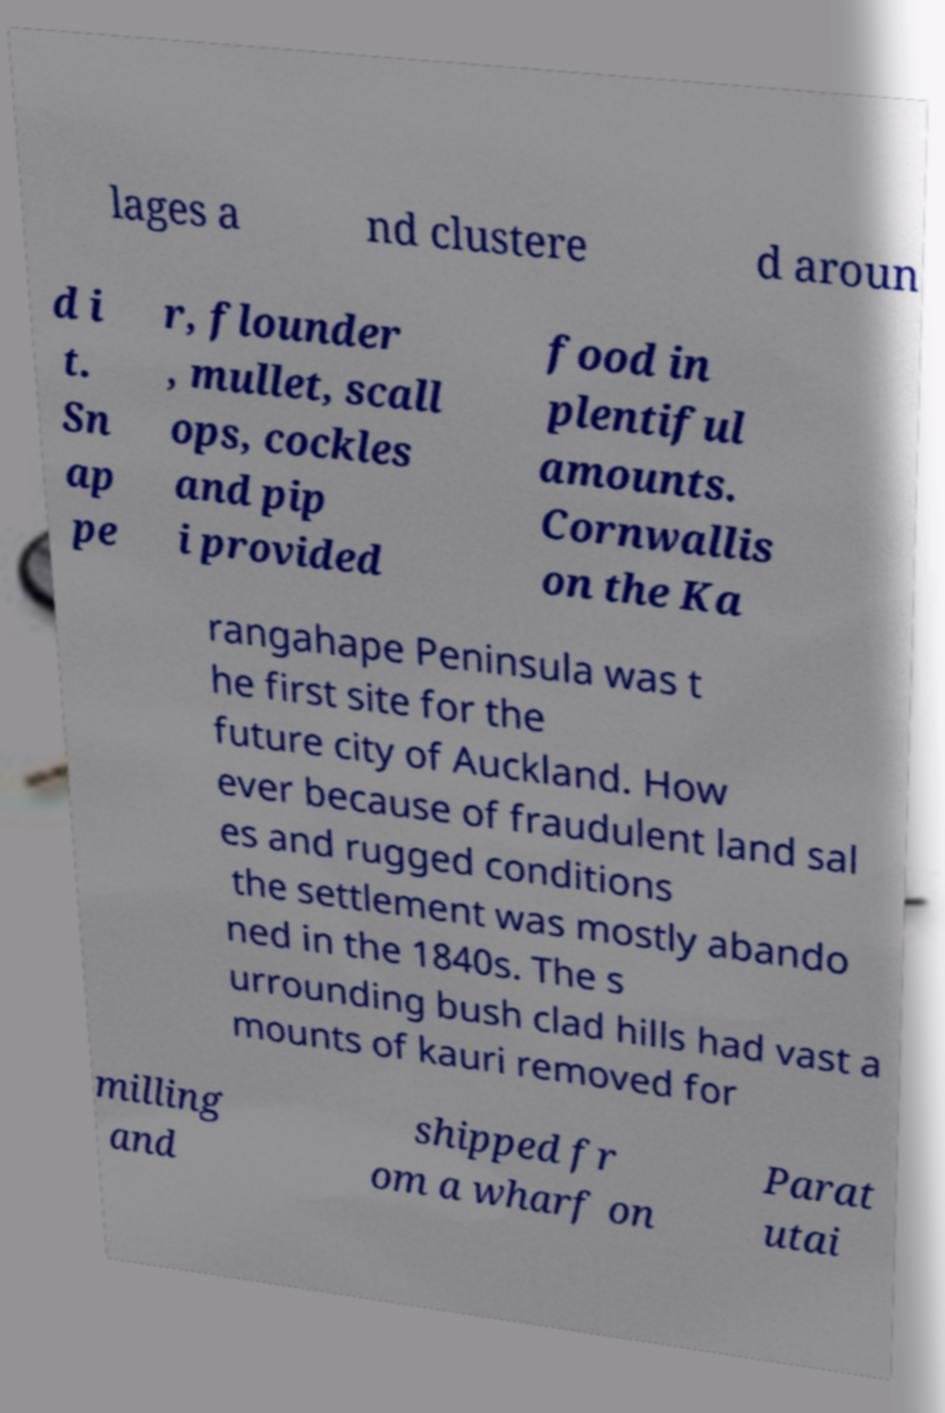Could you extract and type out the text from this image? lages a nd clustere d aroun d i t. Sn ap pe r, flounder , mullet, scall ops, cockles and pip i provided food in plentiful amounts. Cornwallis on the Ka rangahape Peninsula was t he first site for the future city of Auckland. How ever because of fraudulent land sal es and rugged conditions the settlement was mostly abando ned in the 1840s. The s urrounding bush clad hills had vast a mounts of kauri removed for milling and shipped fr om a wharf on Parat utai 